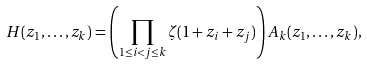Convert formula to latex. <formula><loc_0><loc_0><loc_500><loc_500>H ( z _ { 1 } , \dots , z _ { k } ) = \left ( \prod _ { 1 \leq i < j \leq k } \zeta ( 1 + z _ { i } + z _ { j } ) \right ) A _ { k } ( z _ { 1 } , \dots , z _ { k } ) ,</formula> 